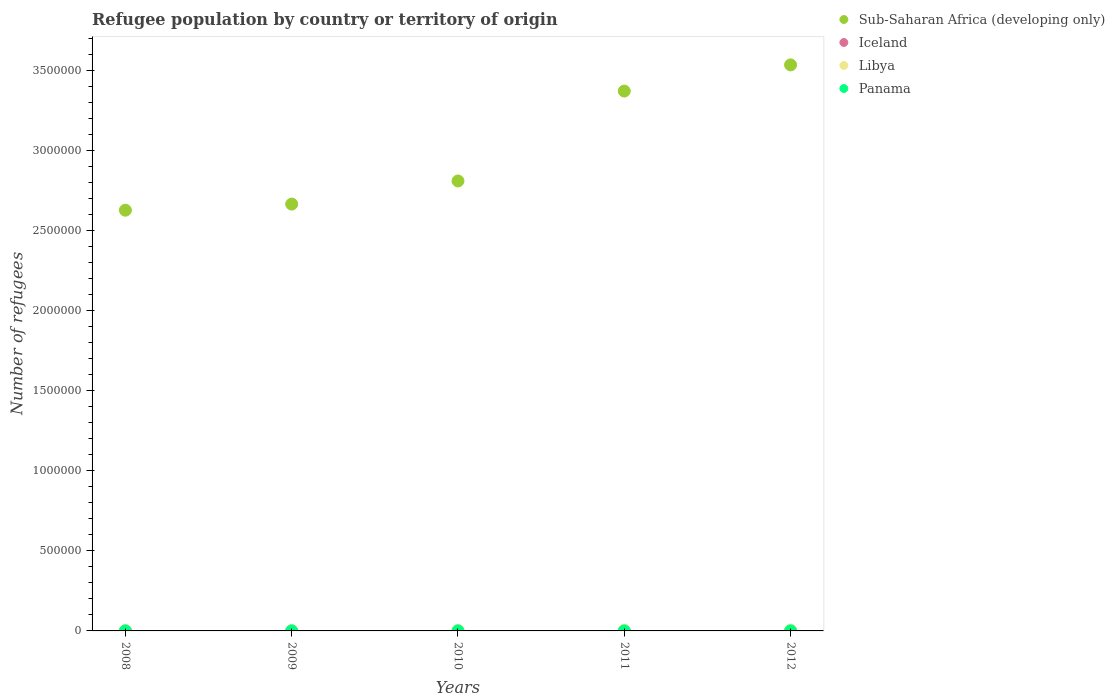What is the number of refugees in Panama in 2008?
Ensure brevity in your answer.  111. Across all years, what is the maximum number of refugees in Libya?
Keep it short and to the point. 5251. Across all years, what is the minimum number of refugees in Iceland?
Your response must be concise. 3. In which year was the number of refugees in Libya minimum?
Your response must be concise. 2008. What is the total number of refugees in Sub-Saharan Africa (developing only) in the graph?
Keep it short and to the point. 1.50e+07. What is the difference between the number of refugees in Libya in 2009 and that in 2011?
Ensure brevity in your answer.  -2182. What is the difference between the number of refugees in Libya in 2011 and the number of refugees in Iceland in 2008?
Give a very brief answer. 4377. What is the average number of refugees in Sub-Saharan Africa (developing only) per year?
Offer a very short reply. 3.00e+06. In the year 2011, what is the difference between the number of refugees in Panama and number of refugees in Sub-Saharan Africa (developing only)?
Provide a short and direct response. -3.37e+06. What is the ratio of the number of refugees in Iceland in 2010 to that in 2011?
Your answer should be very brief. 1.33. Is the number of refugees in Sub-Saharan Africa (developing only) in 2009 less than that in 2012?
Provide a succinct answer. Yes. What is the difference between the highest and the second highest number of refugees in Libya?
Your answer should be very brief. 867. What is the difference between the highest and the lowest number of refugees in Iceland?
Provide a succinct answer. 4. In how many years, is the number of refugees in Iceland greater than the average number of refugees in Iceland taken over all years?
Make the answer very short. 1. Is the sum of the number of refugees in Libya in 2010 and 2012 greater than the maximum number of refugees in Iceland across all years?
Offer a terse response. Yes. Is it the case that in every year, the sum of the number of refugees in Sub-Saharan Africa (developing only) and number of refugees in Iceland  is greater than the sum of number of refugees in Libya and number of refugees in Panama?
Your answer should be very brief. No. Is it the case that in every year, the sum of the number of refugees in Sub-Saharan Africa (developing only) and number of refugees in Libya  is greater than the number of refugees in Iceland?
Keep it short and to the point. Yes. Does the number of refugees in Sub-Saharan Africa (developing only) monotonically increase over the years?
Your response must be concise. Yes. Is the number of refugees in Sub-Saharan Africa (developing only) strictly less than the number of refugees in Libya over the years?
Ensure brevity in your answer.  No. How many years are there in the graph?
Ensure brevity in your answer.  5. What is the difference between two consecutive major ticks on the Y-axis?
Your answer should be compact. 5.00e+05. Are the values on the major ticks of Y-axis written in scientific E-notation?
Provide a short and direct response. No. Does the graph contain grids?
Ensure brevity in your answer.  No. Where does the legend appear in the graph?
Give a very brief answer. Top right. How are the legend labels stacked?
Keep it short and to the point. Vertical. What is the title of the graph?
Offer a very short reply. Refugee population by country or territory of origin. What is the label or title of the X-axis?
Your response must be concise. Years. What is the label or title of the Y-axis?
Provide a succinct answer. Number of refugees. What is the Number of refugees in Sub-Saharan Africa (developing only) in 2008?
Ensure brevity in your answer.  2.63e+06. What is the Number of refugees of Iceland in 2008?
Your answer should be very brief. 7. What is the Number of refugees in Libya in 2008?
Your response must be concise. 2084. What is the Number of refugees in Panama in 2008?
Ensure brevity in your answer.  111. What is the Number of refugees of Sub-Saharan Africa (developing only) in 2009?
Your answer should be very brief. 2.67e+06. What is the Number of refugees of Libya in 2009?
Give a very brief answer. 2202. What is the Number of refugees in Panama in 2009?
Provide a short and direct response. 105. What is the Number of refugees of Sub-Saharan Africa (developing only) in 2010?
Keep it short and to the point. 2.81e+06. What is the Number of refugees in Libya in 2010?
Provide a succinct answer. 2309. What is the Number of refugees of Panama in 2010?
Keep it short and to the point. 100. What is the Number of refugees in Sub-Saharan Africa (developing only) in 2011?
Provide a short and direct response. 3.37e+06. What is the Number of refugees of Iceland in 2011?
Your answer should be compact. 3. What is the Number of refugees of Libya in 2011?
Ensure brevity in your answer.  4384. What is the Number of refugees in Sub-Saharan Africa (developing only) in 2012?
Provide a short and direct response. 3.54e+06. What is the Number of refugees in Libya in 2012?
Your answer should be very brief. 5251. What is the Number of refugees in Panama in 2012?
Your response must be concise. 107. Across all years, what is the maximum Number of refugees in Sub-Saharan Africa (developing only)?
Your answer should be compact. 3.54e+06. Across all years, what is the maximum Number of refugees in Iceland?
Offer a very short reply. 7. Across all years, what is the maximum Number of refugees of Libya?
Ensure brevity in your answer.  5251. Across all years, what is the maximum Number of refugees of Panama?
Make the answer very short. 111. Across all years, what is the minimum Number of refugees of Sub-Saharan Africa (developing only)?
Your answer should be compact. 2.63e+06. Across all years, what is the minimum Number of refugees in Iceland?
Give a very brief answer. 3. Across all years, what is the minimum Number of refugees in Libya?
Provide a succinct answer. 2084. Across all years, what is the minimum Number of refugees of Panama?
Provide a succinct answer. 100. What is the total Number of refugees in Sub-Saharan Africa (developing only) in the graph?
Your response must be concise. 1.50e+07. What is the total Number of refugees of Libya in the graph?
Provide a short and direct response. 1.62e+04. What is the total Number of refugees of Panama in the graph?
Give a very brief answer. 523. What is the difference between the Number of refugees in Sub-Saharan Africa (developing only) in 2008 and that in 2009?
Offer a terse response. -3.81e+04. What is the difference between the Number of refugees of Iceland in 2008 and that in 2009?
Provide a short and direct response. 3. What is the difference between the Number of refugees of Libya in 2008 and that in 2009?
Ensure brevity in your answer.  -118. What is the difference between the Number of refugees in Panama in 2008 and that in 2009?
Ensure brevity in your answer.  6. What is the difference between the Number of refugees of Sub-Saharan Africa (developing only) in 2008 and that in 2010?
Keep it short and to the point. -1.82e+05. What is the difference between the Number of refugees in Iceland in 2008 and that in 2010?
Make the answer very short. 3. What is the difference between the Number of refugees in Libya in 2008 and that in 2010?
Offer a terse response. -225. What is the difference between the Number of refugees of Sub-Saharan Africa (developing only) in 2008 and that in 2011?
Offer a terse response. -7.44e+05. What is the difference between the Number of refugees of Iceland in 2008 and that in 2011?
Offer a very short reply. 4. What is the difference between the Number of refugees in Libya in 2008 and that in 2011?
Your answer should be compact. -2300. What is the difference between the Number of refugees of Panama in 2008 and that in 2011?
Provide a short and direct response. 11. What is the difference between the Number of refugees in Sub-Saharan Africa (developing only) in 2008 and that in 2012?
Provide a short and direct response. -9.07e+05. What is the difference between the Number of refugees in Iceland in 2008 and that in 2012?
Provide a short and direct response. 4. What is the difference between the Number of refugees in Libya in 2008 and that in 2012?
Offer a very short reply. -3167. What is the difference between the Number of refugees of Panama in 2008 and that in 2012?
Give a very brief answer. 4. What is the difference between the Number of refugees of Sub-Saharan Africa (developing only) in 2009 and that in 2010?
Give a very brief answer. -1.44e+05. What is the difference between the Number of refugees in Iceland in 2009 and that in 2010?
Keep it short and to the point. 0. What is the difference between the Number of refugees in Libya in 2009 and that in 2010?
Offer a very short reply. -107. What is the difference between the Number of refugees in Panama in 2009 and that in 2010?
Make the answer very short. 5. What is the difference between the Number of refugees of Sub-Saharan Africa (developing only) in 2009 and that in 2011?
Your answer should be compact. -7.06e+05. What is the difference between the Number of refugees in Libya in 2009 and that in 2011?
Provide a succinct answer. -2182. What is the difference between the Number of refugees in Panama in 2009 and that in 2011?
Give a very brief answer. 5. What is the difference between the Number of refugees of Sub-Saharan Africa (developing only) in 2009 and that in 2012?
Offer a terse response. -8.69e+05. What is the difference between the Number of refugees in Libya in 2009 and that in 2012?
Provide a short and direct response. -3049. What is the difference between the Number of refugees in Sub-Saharan Africa (developing only) in 2010 and that in 2011?
Your answer should be very brief. -5.62e+05. What is the difference between the Number of refugees in Libya in 2010 and that in 2011?
Your answer should be compact. -2075. What is the difference between the Number of refugees of Panama in 2010 and that in 2011?
Your answer should be compact. 0. What is the difference between the Number of refugees of Sub-Saharan Africa (developing only) in 2010 and that in 2012?
Give a very brief answer. -7.25e+05. What is the difference between the Number of refugees of Iceland in 2010 and that in 2012?
Your answer should be compact. 1. What is the difference between the Number of refugees in Libya in 2010 and that in 2012?
Keep it short and to the point. -2942. What is the difference between the Number of refugees of Sub-Saharan Africa (developing only) in 2011 and that in 2012?
Your response must be concise. -1.64e+05. What is the difference between the Number of refugees in Libya in 2011 and that in 2012?
Your answer should be very brief. -867. What is the difference between the Number of refugees in Sub-Saharan Africa (developing only) in 2008 and the Number of refugees in Iceland in 2009?
Your response must be concise. 2.63e+06. What is the difference between the Number of refugees of Sub-Saharan Africa (developing only) in 2008 and the Number of refugees of Libya in 2009?
Your answer should be very brief. 2.63e+06. What is the difference between the Number of refugees of Sub-Saharan Africa (developing only) in 2008 and the Number of refugees of Panama in 2009?
Make the answer very short. 2.63e+06. What is the difference between the Number of refugees of Iceland in 2008 and the Number of refugees of Libya in 2009?
Your answer should be compact. -2195. What is the difference between the Number of refugees of Iceland in 2008 and the Number of refugees of Panama in 2009?
Offer a very short reply. -98. What is the difference between the Number of refugees of Libya in 2008 and the Number of refugees of Panama in 2009?
Keep it short and to the point. 1979. What is the difference between the Number of refugees in Sub-Saharan Africa (developing only) in 2008 and the Number of refugees in Iceland in 2010?
Offer a very short reply. 2.63e+06. What is the difference between the Number of refugees in Sub-Saharan Africa (developing only) in 2008 and the Number of refugees in Libya in 2010?
Provide a short and direct response. 2.63e+06. What is the difference between the Number of refugees of Sub-Saharan Africa (developing only) in 2008 and the Number of refugees of Panama in 2010?
Keep it short and to the point. 2.63e+06. What is the difference between the Number of refugees in Iceland in 2008 and the Number of refugees in Libya in 2010?
Keep it short and to the point. -2302. What is the difference between the Number of refugees of Iceland in 2008 and the Number of refugees of Panama in 2010?
Keep it short and to the point. -93. What is the difference between the Number of refugees in Libya in 2008 and the Number of refugees in Panama in 2010?
Offer a terse response. 1984. What is the difference between the Number of refugees of Sub-Saharan Africa (developing only) in 2008 and the Number of refugees of Iceland in 2011?
Your response must be concise. 2.63e+06. What is the difference between the Number of refugees in Sub-Saharan Africa (developing only) in 2008 and the Number of refugees in Libya in 2011?
Ensure brevity in your answer.  2.62e+06. What is the difference between the Number of refugees of Sub-Saharan Africa (developing only) in 2008 and the Number of refugees of Panama in 2011?
Your response must be concise. 2.63e+06. What is the difference between the Number of refugees in Iceland in 2008 and the Number of refugees in Libya in 2011?
Your answer should be very brief. -4377. What is the difference between the Number of refugees of Iceland in 2008 and the Number of refugees of Panama in 2011?
Make the answer very short. -93. What is the difference between the Number of refugees in Libya in 2008 and the Number of refugees in Panama in 2011?
Offer a terse response. 1984. What is the difference between the Number of refugees in Sub-Saharan Africa (developing only) in 2008 and the Number of refugees in Iceland in 2012?
Make the answer very short. 2.63e+06. What is the difference between the Number of refugees of Sub-Saharan Africa (developing only) in 2008 and the Number of refugees of Libya in 2012?
Ensure brevity in your answer.  2.62e+06. What is the difference between the Number of refugees of Sub-Saharan Africa (developing only) in 2008 and the Number of refugees of Panama in 2012?
Ensure brevity in your answer.  2.63e+06. What is the difference between the Number of refugees in Iceland in 2008 and the Number of refugees in Libya in 2012?
Offer a very short reply. -5244. What is the difference between the Number of refugees in Iceland in 2008 and the Number of refugees in Panama in 2012?
Provide a succinct answer. -100. What is the difference between the Number of refugees of Libya in 2008 and the Number of refugees of Panama in 2012?
Keep it short and to the point. 1977. What is the difference between the Number of refugees of Sub-Saharan Africa (developing only) in 2009 and the Number of refugees of Iceland in 2010?
Offer a very short reply. 2.67e+06. What is the difference between the Number of refugees in Sub-Saharan Africa (developing only) in 2009 and the Number of refugees in Libya in 2010?
Your answer should be compact. 2.66e+06. What is the difference between the Number of refugees in Sub-Saharan Africa (developing only) in 2009 and the Number of refugees in Panama in 2010?
Keep it short and to the point. 2.67e+06. What is the difference between the Number of refugees of Iceland in 2009 and the Number of refugees of Libya in 2010?
Offer a very short reply. -2305. What is the difference between the Number of refugees in Iceland in 2009 and the Number of refugees in Panama in 2010?
Keep it short and to the point. -96. What is the difference between the Number of refugees of Libya in 2009 and the Number of refugees of Panama in 2010?
Your response must be concise. 2102. What is the difference between the Number of refugees in Sub-Saharan Africa (developing only) in 2009 and the Number of refugees in Iceland in 2011?
Offer a terse response. 2.67e+06. What is the difference between the Number of refugees in Sub-Saharan Africa (developing only) in 2009 and the Number of refugees in Libya in 2011?
Give a very brief answer. 2.66e+06. What is the difference between the Number of refugees in Sub-Saharan Africa (developing only) in 2009 and the Number of refugees in Panama in 2011?
Offer a very short reply. 2.67e+06. What is the difference between the Number of refugees of Iceland in 2009 and the Number of refugees of Libya in 2011?
Your answer should be compact. -4380. What is the difference between the Number of refugees in Iceland in 2009 and the Number of refugees in Panama in 2011?
Offer a very short reply. -96. What is the difference between the Number of refugees in Libya in 2009 and the Number of refugees in Panama in 2011?
Provide a succinct answer. 2102. What is the difference between the Number of refugees in Sub-Saharan Africa (developing only) in 2009 and the Number of refugees in Iceland in 2012?
Provide a short and direct response. 2.67e+06. What is the difference between the Number of refugees of Sub-Saharan Africa (developing only) in 2009 and the Number of refugees of Libya in 2012?
Offer a very short reply. 2.66e+06. What is the difference between the Number of refugees in Sub-Saharan Africa (developing only) in 2009 and the Number of refugees in Panama in 2012?
Ensure brevity in your answer.  2.67e+06. What is the difference between the Number of refugees of Iceland in 2009 and the Number of refugees of Libya in 2012?
Your answer should be compact. -5247. What is the difference between the Number of refugees in Iceland in 2009 and the Number of refugees in Panama in 2012?
Your answer should be compact. -103. What is the difference between the Number of refugees of Libya in 2009 and the Number of refugees of Panama in 2012?
Provide a succinct answer. 2095. What is the difference between the Number of refugees in Sub-Saharan Africa (developing only) in 2010 and the Number of refugees in Iceland in 2011?
Make the answer very short. 2.81e+06. What is the difference between the Number of refugees of Sub-Saharan Africa (developing only) in 2010 and the Number of refugees of Libya in 2011?
Make the answer very short. 2.81e+06. What is the difference between the Number of refugees of Sub-Saharan Africa (developing only) in 2010 and the Number of refugees of Panama in 2011?
Your response must be concise. 2.81e+06. What is the difference between the Number of refugees of Iceland in 2010 and the Number of refugees of Libya in 2011?
Keep it short and to the point. -4380. What is the difference between the Number of refugees in Iceland in 2010 and the Number of refugees in Panama in 2011?
Your answer should be compact. -96. What is the difference between the Number of refugees in Libya in 2010 and the Number of refugees in Panama in 2011?
Your response must be concise. 2209. What is the difference between the Number of refugees of Sub-Saharan Africa (developing only) in 2010 and the Number of refugees of Iceland in 2012?
Your answer should be compact. 2.81e+06. What is the difference between the Number of refugees in Sub-Saharan Africa (developing only) in 2010 and the Number of refugees in Libya in 2012?
Your answer should be very brief. 2.80e+06. What is the difference between the Number of refugees in Sub-Saharan Africa (developing only) in 2010 and the Number of refugees in Panama in 2012?
Your response must be concise. 2.81e+06. What is the difference between the Number of refugees of Iceland in 2010 and the Number of refugees of Libya in 2012?
Ensure brevity in your answer.  -5247. What is the difference between the Number of refugees in Iceland in 2010 and the Number of refugees in Panama in 2012?
Provide a succinct answer. -103. What is the difference between the Number of refugees in Libya in 2010 and the Number of refugees in Panama in 2012?
Provide a succinct answer. 2202. What is the difference between the Number of refugees in Sub-Saharan Africa (developing only) in 2011 and the Number of refugees in Iceland in 2012?
Provide a short and direct response. 3.37e+06. What is the difference between the Number of refugees in Sub-Saharan Africa (developing only) in 2011 and the Number of refugees in Libya in 2012?
Provide a short and direct response. 3.37e+06. What is the difference between the Number of refugees in Sub-Saharan Africa (developing only) in 2011 and the Number of refugees in Panama in 2012?
Provide a succinct answer. 3.37e+06. What is the difference between the Number of refugees of Iceland in 2011 and the Number of refugees of Libya in 2012?
Offer a very short reply. -5248. What is the difference between the Number of refugees in Iceland in 2011 and the Number of refugees in Panama in 2012?
Make the answer very short. -104. What is the difference between the Number of refugees in Libya in 2011 and the Number of refugees in Panama in 2012?
Your answer should be very brief. 4277. What is the average Number of refugees of Sub-Saharan Africa (developing only) per year?
Provide a succinct answer. 3.00e+06. What is the average Number of refugees of Iceland per year?
Offer a very short reply. 4.2. What is the average Number of refugees of Libya per year?
Give a very brief answer. 3246. What is the average Number of refugees in Panama per year?
Offer a very short reply. 104.6. In the year 2008, what is the difference between the Number of refugees in Sub-Saharan Africa (developing only) and Number of refugees in Iceland?
Your response must be concise. 2.63e+06. In the year 2008, what is the difference between the Number of refugees of Sub-Saharan Africa (developing only) and Number of refugees of Libya?
Your answer should be compact. 2.63e+06. In the year 2008, what is the difference between the Number of refugees of Sub-Saharan Africa (developing only) and Number of refugees of Panama?
Provide a succinct answer. 2.63e+06. In the year 2008, what is the difference between the Number of refugees in Iceland and Number of refugees in Libya?
Offer a terse response. -2077. In the year 2008, what is the difference between the Number of refugees of Iceland and Number of refugees of Panama?
Your answer should be compact. -104. In the year 2008, what is the difference between the Number of refugees in Libya and Number of refugees in Panama?
Your answer should be very brief. 1973. In the year 2009, what is the difference between the Number of refugees in Sub-Saharan Africa (developing only) and Number of refugees in Iceland?
Provide a short and direct response. 2.67e+06. In the year 2009, what is the difference between the Number of refugees of Sub-Saharan Africa (developing only) and Number of refugees of Libya?
Give a very brief answer. 2.66e+06. In the year 2009, what is the difference between the Number of refugees in Sub-Saharan Africa (developing only) and Number of refugees in Panama?
Your answer should be compact. 2.67e+06. In the year 2009, what is the difference between the Number of refugees of Iceland and Number of refugees of Libya?
Your answer should be compact. -2198. In the year 2009, what is the difference between the Number of refugees of Iceland and Number of refugees of Panama?
Offer a terse response. -101. In the year 2009, what is the difference between the Number of refugees of Libya and Number of refugees of Panama?
Keep it short and to the point. 2097. In the year 2010, what is the difference between the Number of refugees in Sub-Saharan Africa (developing only) and Number of refugees in Iceland?
Your response must be concise. 2.81e+06. In the year 2010, what is the difference between the Number of refugees of Sub-Saharan Africa (developing only) and Number of refugees of Libya?
Offer a terse response. 2.81e+06. In the year 2010, what is the difference between the Number of refugees of Sub-Saharan Africa (developing only) and Number of refugees of Panama?
Your response must be concise. 2.81e+06. In the year 2010, what is the difference between the Number of refugees of Iceland and Number of refugees of Libya?
Provide a succinct answer. -2305. In the year 2010, what is the difference between the Number of refugees of Iceland and Number of refugees of Panama?
Make the answer very short. -96. In the year 2010, what is the difference between the Number of refugees in Libya and Number of refugees in Panama?
Make the answer very short. 2209. In the year 2011, what is the difference between the Number of refugees of Sub-Saharan Africa (developing only) and Number of refugees of Iceland?
Make the answer very short. 3.37e+06. In the year 2011, what is the difference between the Number of refugees in Sub-Saharan Africa (developing only) and Number of refugees in Libya?
Provide a succinct answer. 3.37e+06. In the year 2011, what is the difference between the Number of refugees of Sub-Saharan Africa (developing only) and Number of refugees of Panama?
Make the answer very short. 3.37e+06. In the year 2011, what is the difference between the Number of refugees in Iceland and Number of refugees in Libya?
Your answer should be compact. -4381. In the year 2011, what is the difference between the Number of refugees in Iceland and Number of refugees in Panama?
Your answer should be compact. -97. In the year 2011, what is the difference between the Number of refugees in Libya and Number of refugees in Panama?
Provide a short and direct response. 4284. In the year 2012, what is the difference between the Number of refugees of Sub-Saharan Africa (developing only) and Number of refugees of Iceland?
Provide a succinct answer. 3.54e+06. In the year 2012, what is the difference between the Number of refugees of Sub-Saharan Africa (developing only) and Number of refugees of Libya?
Provide a short and direct response. 3.53e+06. In the year 2012, what is the difference between the Number of refugees in Sub-Saharan Africa (developing only) and Number of refugees in Panama?
Make the answer very short. 3.54e+06. In the year 2012, what is the difference between the Number of refugees in Iceland and Number of refugees in Libya?
Make the answer very short. -5248. In the year 2012, what is the difference between the Number of refugees of Iceland and Number of refugees of Panama?
Your response must be concise. -104. In the year 2012, what is the difference between the Number of refugees of Libya and Number of refugees of Panama?
Make the answer very short. 5144. What is the ratio of the Number of refugees of Sub-Saharan Africa (developing only) in 2008 to that in 2009?
Ensure brevity in your answer.  0.99. What is the ratio of the Number of refugees in Iceland in 2008 to that in 2009?
Keep it short and to the point. 1.75. What is the ratio of the Number of refugees in Libya in 2008 to that in 2009?
Your response must be concise. 0.95. What is the ratio of the Number of refugees in Panama in 2008 to that in 2009?
Your answer should be very brief. 1.06. What is the ratio of the Number of refugees in Sub-Saharan Africa (developing only) in 2008 to that in 2010?
Give a very brief answer. 0.94. What is the ratio of the Number of refugees of Iceland in 2008 to that in 2010?
Offer a terse response. 1.75. What is the ratio of the Number of refugees of Libya in 2008 to that in 2010?
Your answer should be very brief. 0.9. What is the ratio of the Number of refugees of Panama in 2008 to that in 2010?
Offer a very short reply. 1.11. What is the ratio of the Number of refugees of Sub-Saharan Africa (developing only) in 2008 to that in 2011?
Your response must be concise. 0.78. What is the ratio of the Number of refugees in Iceland in 2008 to that in 2011?
Your response must be concise. 2.33. What is the ratio of the Number of refugees in Libya in 2008 to that in 2011?
Ensure brevity in your answer.  0.48. What is the ratio of the Number of refugees in Panama in 2008 to that in 2011?
Give a very brief answer. 1.11. What is the ratio of the Number of refugees in Sub-Saharan Africa (developing only) in 2008 to that in 2012?
Your response must be concise. 0.74. What is the ratio of the Number of refugees of Iceland in 2008 to that in 2012?
Give a very brief answer. 2.33. What is the ratio of the Number of refugees in Libya in 2008 to that in 2012?
Your answer should be compact. 0.4. What is the ratio of the Number of refugees in Panama in 2008 to that in 2012?
Offer a very short reply. 1.04. What is the ratio of the Number of refugees in Sub-Saharan Africa (developing only) in 2009 to that in 2010?
Offer a very short reply. 0.95. What is the ratio of the Number of refugees in Libya in 2009 to that in 2010?
Make the answer very short. 0.95. What is the ratio of the Number of refugees of Panama in 2009 to that in 2010?
Your answer should be compact. 1.05. What is the ratio of the Number of refugees of Sub-Saharan Africa (developing only) in 2009 to that in 2011?
Provide a succinct answer. 0.79. What is the ratio of the Number of refugees in Libya in 2009 to that in 2011?
Make the answer very short. 0.5. What is the ratio of the Number of refugees in Panama in 2009 to that in 2011?
Ensure brevity in your answer.  1.05. What is the ratio of the Number of refugees in Sub-Saharan Africa (developing only) in 2009 to that in 2012?
Give a very brief answer. 0.75. What is the ratio of the Number of refugees in Libya in 2009 to that in 2012?
Provide a short and direct response. 0.42. What is the ratio of the Number of refugees in Panama in 2009 to that in 2012?
Offer a very short reply. 0.98. What is the ratio of the Number of refugees in Sub-Saharan Africa (developing only) in 2010 to that in 2011?
Offer a very short reply. 0.83. What is the ratio of the Number of refugees of Iceland in 2010 to that in 2011?
Give a very brief answer. 1.33. What is the ratio of the Number of refugees of Libya in 2010 to that in 2011?
Your answer should be very brief. 0.53. What is the ratio of the Number of refugees in Sub-Saharan Africa (developing only) in 2010 to that in 2012?
Keep it short and to the point. 0.79. What is the ratio of the Number of refugees in Iceland in 2010 to that in 2012?
Your response must be concise. 1.33. What is the ratio of the Number of refugees of Libya in 2010 to that in 2012?
Offer a terse response. 0.44. What is the ratio of the Number of refugees in Panama in 2010 to that in 2012?
Provide a short and direct response. 0.93. What is the ratio of the Number of refugees in Sub-Saharan Africa (developing only) in 2011 to that in 2012?
Your answer should be very brief. 0.95. What is the ratio of the Number of refugees in Iceland in 2011 to that in 2012?
Ensure brevity in your answer.  1. What is the ratio of the Number of refugees in Libya in 2011 to that in 2012?
Your response must be concise. 0.83. What is the ratio of the Number of refugees in Panama in 2011 to that in 2012?
Offer a terse response. 0.93. What is the difference between the highest and the second highest Number of refugees in Sub-Saharan Africa (developing only)?
Provide a short and direct response. 1.64e+05. What is the difference between the highest and the second highest Number of refugees of Iceland?
Ensure brevity in your answer.  3. What is the difference between the highest and the second highest Number of refugees of Libya?
Ensure brevity in your answer.  867. What is the difference between the highest and the lowest Number of refugees in Sub-Saharan Africa (developing only)?
Offer a very short reply. 9.07e+05. What is the difference between the highest and the lowest Number of refugees of Iceland?
Ensure brevity in your answer.  4. What is the difference between the highest and the lowest Number of refugees in Libya?
Your answer should be very brief. 3167. 